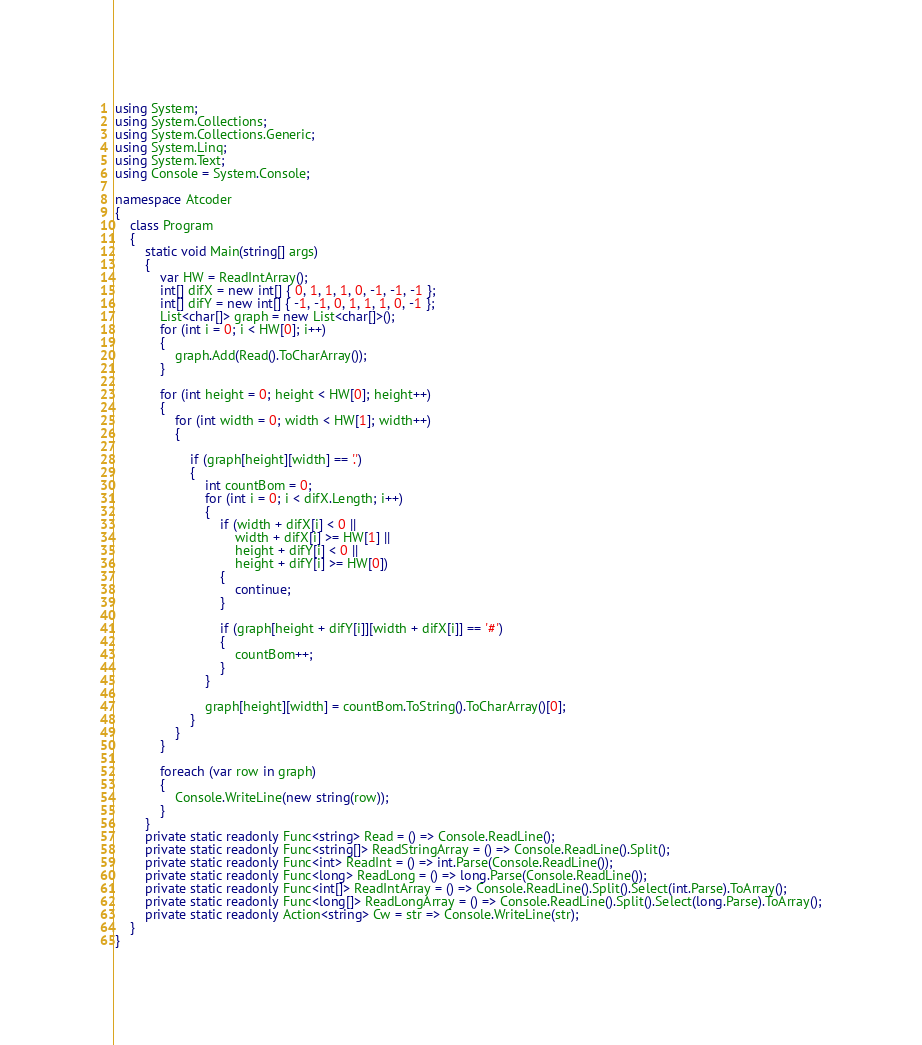<code> <loc_0><loc_0><loc_500><loc_500><_C#_>using System;
using System.Collections;
using System.Collections.Generic;
using System.Linq;
using System.Text;
using Console = System.Console;

namespace Atcoder
{
    class Program
    {
        static void Main(string[] args)
        {
            var HW = ReadIntArray();
            int[] difX = new int[] { 0, 1, 1, 1, 0, -1, -1, -1 };
            int[] difY = new int[] { -1, -1, 0, 1, 1, 1, 0, -1 };
            List<char[]> graph = new List<char[]>();
            for (int i = 0; i < HW[0]; i++)
            {
                graph.Add(Read().ToCharArray());
            }

            for (int height = 0; height < HW[0]; height++)
            {
                for (int width = 0; width < HW[1]; width++)
                {

                    if (graph[height][width] == '.')
                    {
                        int countBom = 0;
                        for (int i = 0; i < difX.Length; i++)
                        {
                            if (width + difX[i] < 0 ||
                                width + difX[i] >= HW[1] ||
                                height + difY[i] < 0 ||
                                height + difY[i] >= HW[0])
                            {
                                continue;
                            }

                            if (graph[height + difY[i]][width + difX[i]] == '#')
                            {
                                countBom++;
                            }
                        }

                        graph[height][width] = countBom.ToString().ToCharArray()[0];
                    }
                }
            }

            foreach (var row in graph)
            {
                Console.WriteLine(new string(row));
            }
        }
        private static readonly Func<string> Read = () => Console.ReadLine();
        private static readonly Func<string[]> ReadStringArray = () => Console.ReadLine().Split();
        private static readonly Func<int> ReadInt = () => int.Parse(Console.ReadLine());
        private static readonly Func<long> ReadLong = () => long.Parse(Console.ReadLine());
        private static readonly Func<int[]> ReadIntArray = () => Console.ReadLine().Split().Select(int.Parse).ToArray();
        private static readonly Func<long[]> ReadLongArray = () => Console.ReadLine().Split().Select(long.Parse).ToArray();
        private static readonly Action<string> Cw = str => Console.WriteLine(str);
    }
}</code> 